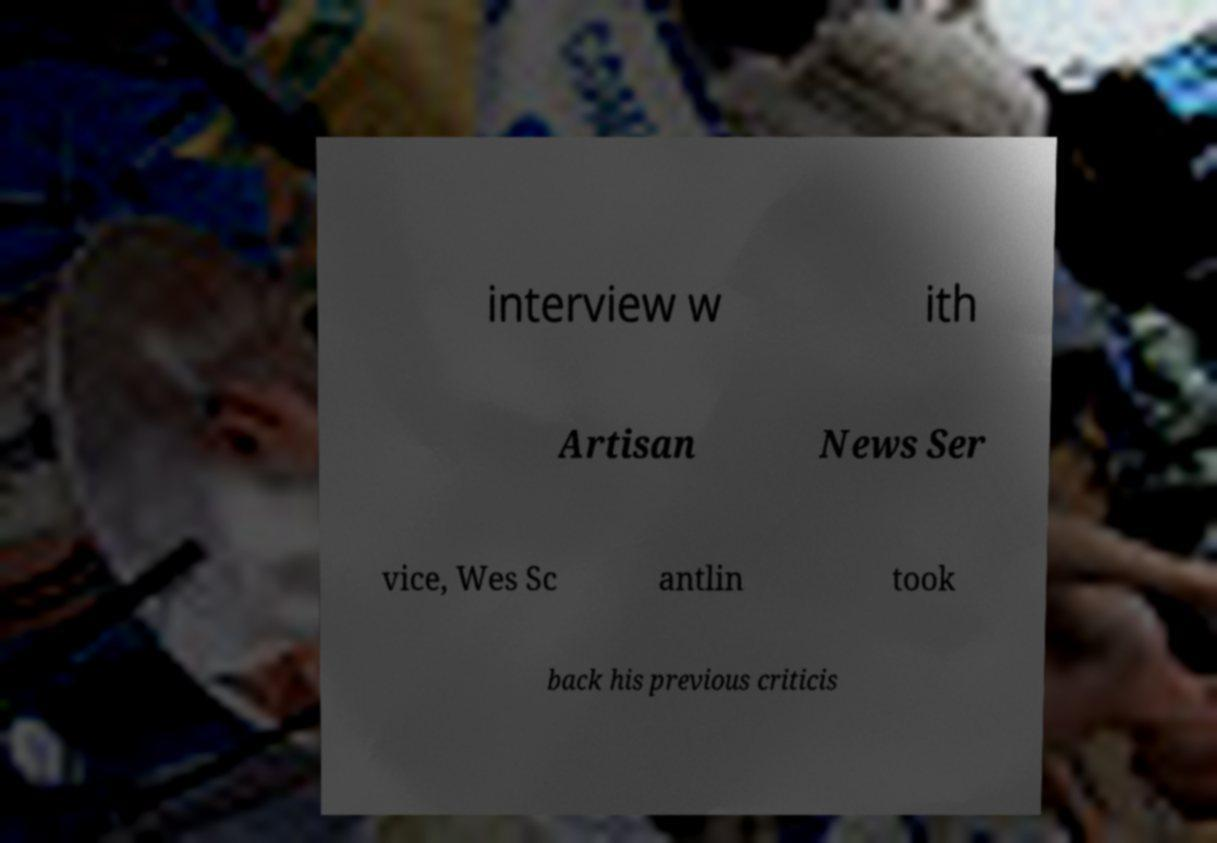There's text embedded in this image that I need extracted. Can you transcribe it verbatim? interview w ith Artisan News Ser vice, Wes Sc antlin took back his previous criticis 